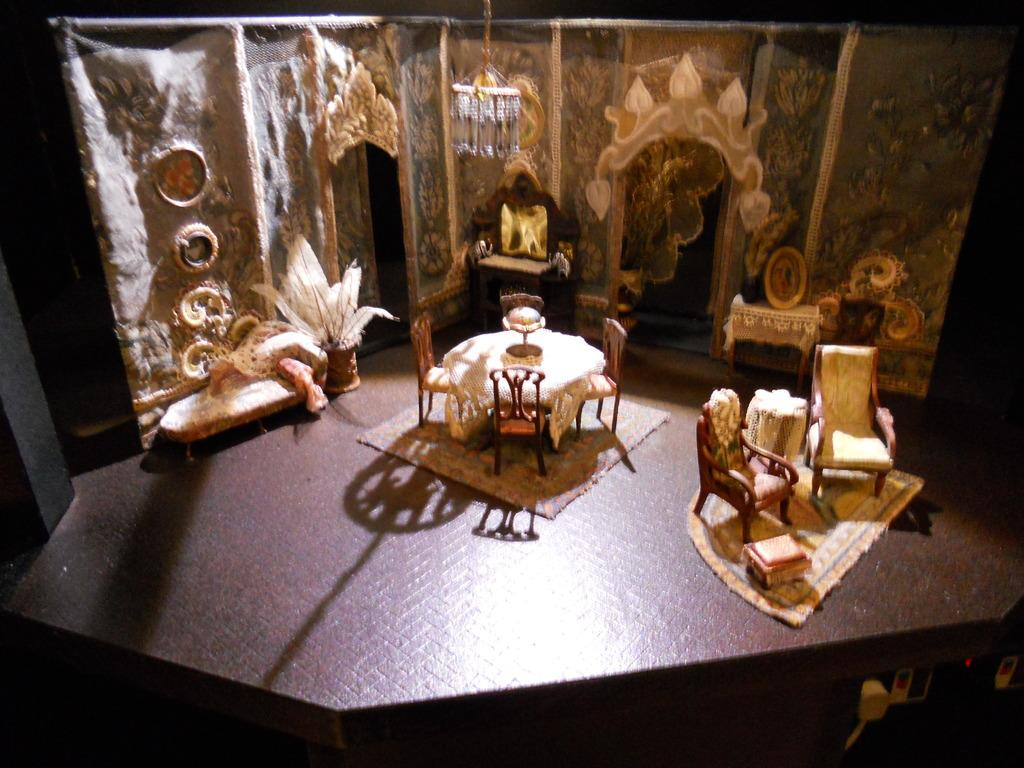What type of toy is present in the image? There is a toy potted plant, a toy light, and a toy mirror in the image. What type of furniture is visible in the image? There are chairs and tables in the image. What is on the table in the image? There are objects on the table in the image. What type of belief is represented by the toy potted plant in the image? The toy potted plant does not represent any belief; it is simply a toy item. 